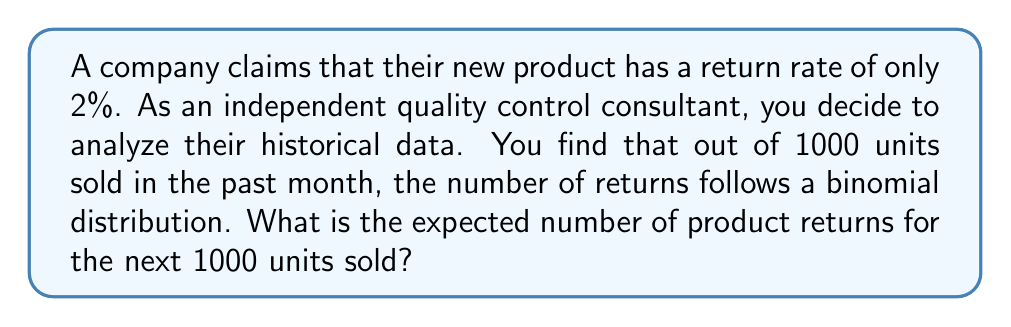Solve this math problem. To solve this problem, we need to use the concept of expected value for a binomial distribution.

1. Identify the parameters of the binomial distribution:
   - $n$ = number of trials (units sold) = 1000
   - $p$ = probability of success (return rate) = 0.02

2. The expected value of a binomial distribution is given by:
   $$ E(X) = np $$

   Where:
   $E(X)$ is the expected value
   $n$ is the number of trials
   $p$ is the probability of success

3. Substitute the values into the formula:
   $$ E(X) = 1000 * 0.02 $$

4. Calculate the result:
   $$ E(X) = 20 $$

As a skeptical consultant, it's important to note that this expected value is based on the company's claimed return rate. It would be prudent to compare this with actual historical data to verify the accuracy of the company's claim.
Answer: The expected number of product returns for the next 1000 units sold is 20. 